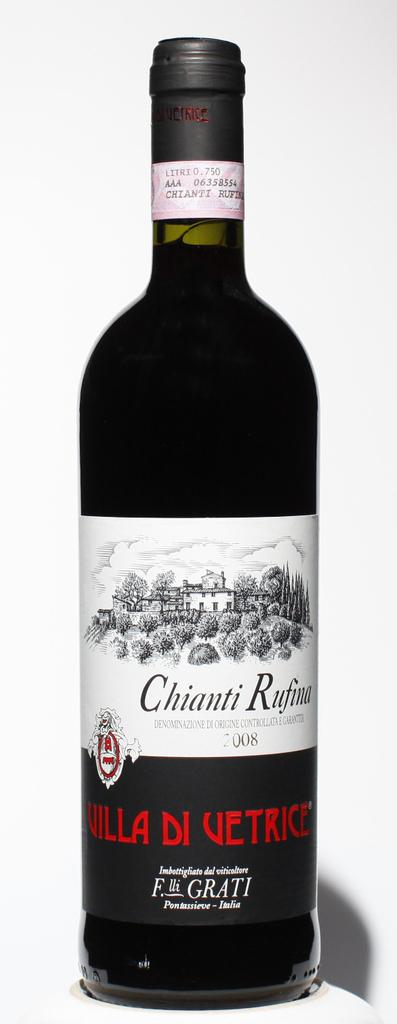<image>
Write a terse but informative summary of the picture. A bottle of Villa Di Vetrice Chianti Rufina is displayed against a white background. 